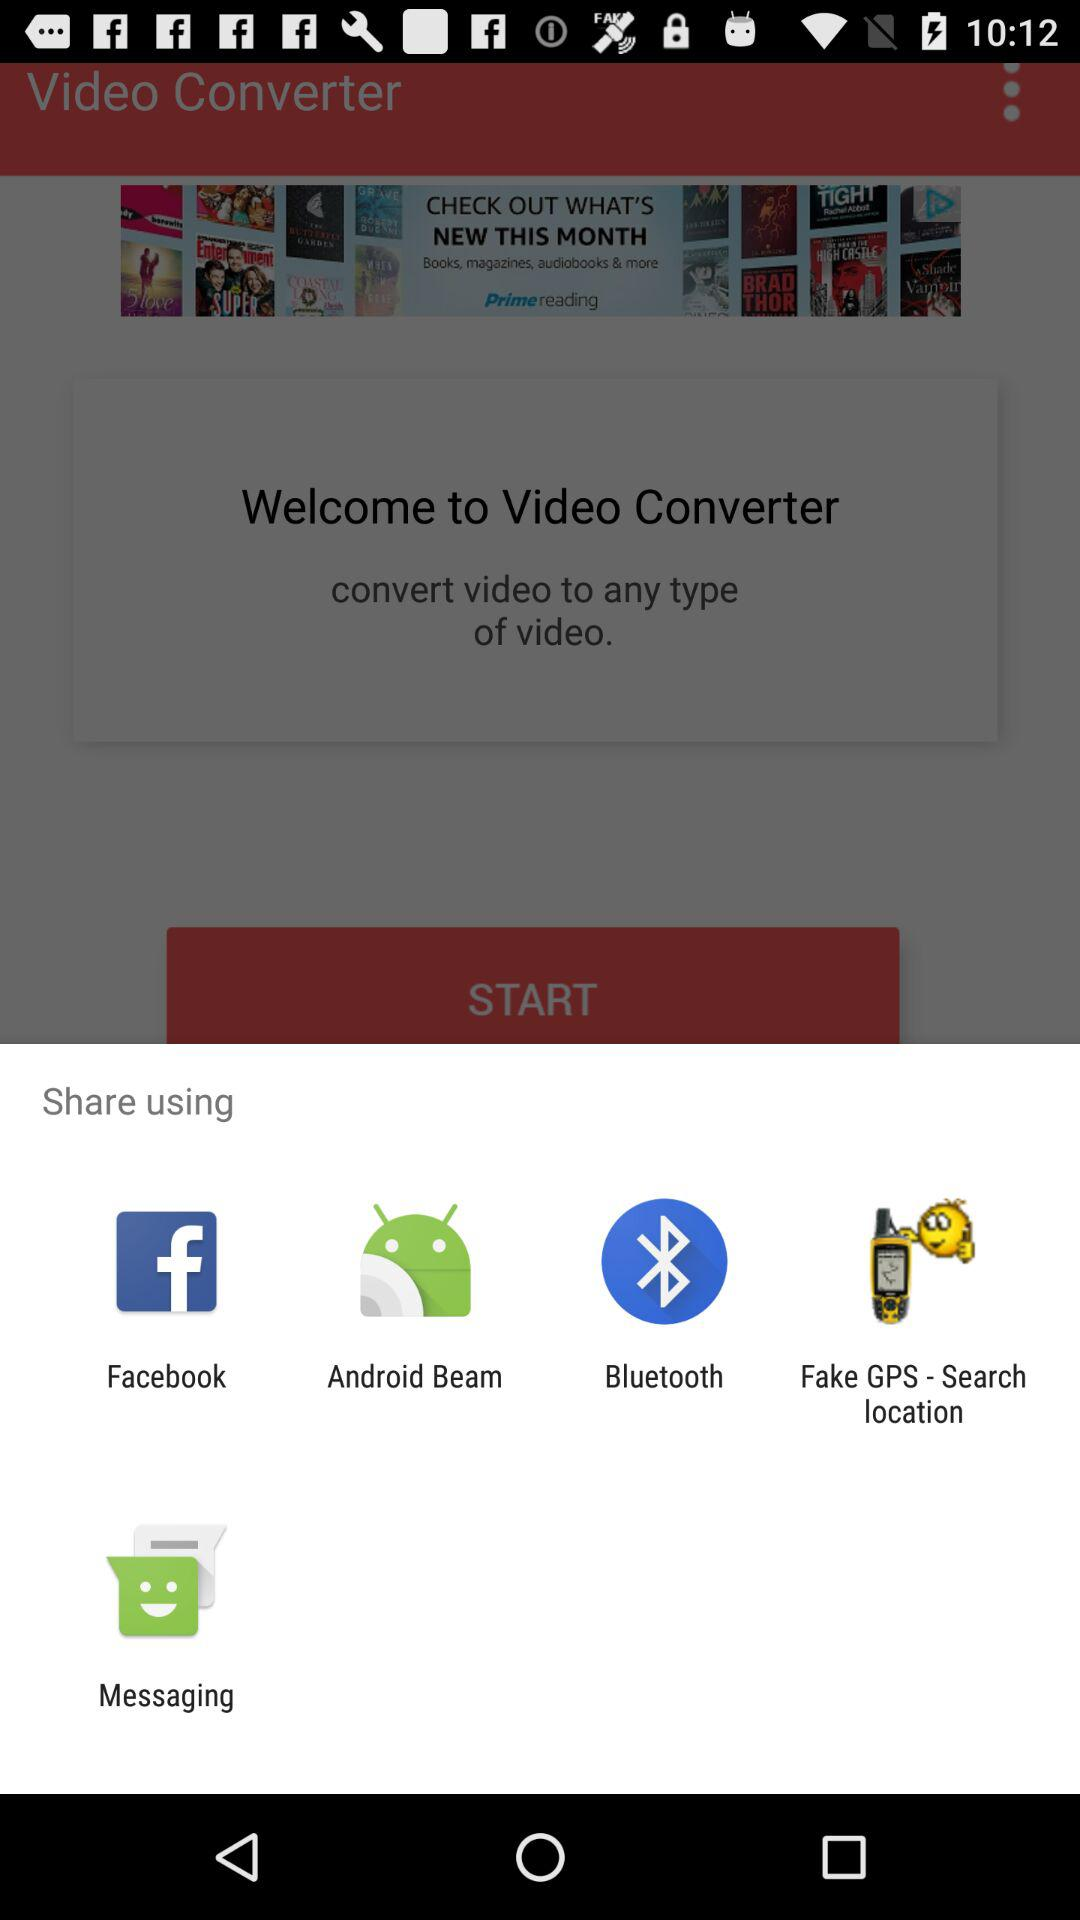What are the different applications through which we can share? The different applications through which we can share are "Facebook", "Android Beam", "Bluetooth", "Fake GPS - Search location" and "Messaging". 